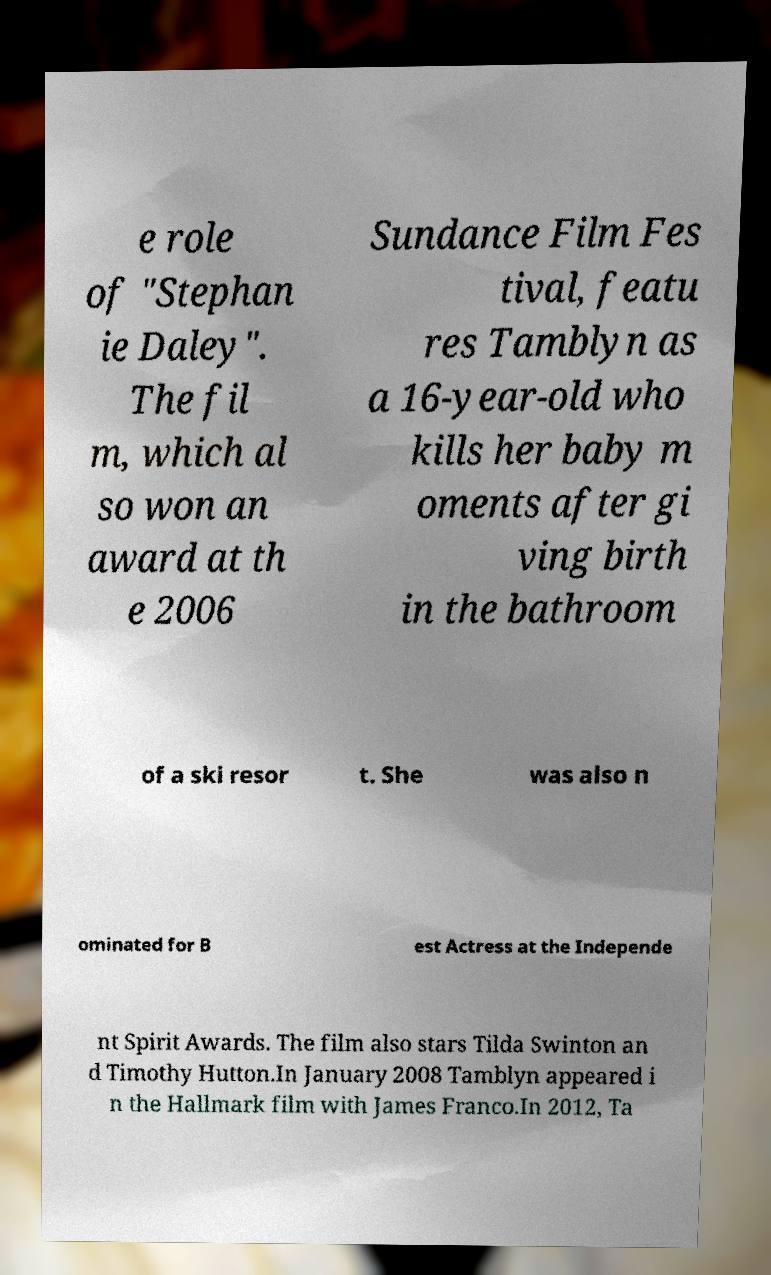Can you read and provide the text displayed in the image?This photo seems to have some interesting text. Can you extract and type it out for me? e role of "Stephan ie Daley". The fil m, which al so won an award at th e 2006 Sundance Film Fes tival, featu res Tamblyn as a 16-year-old who kills her baby m oments after gi ving birth in the bathroom of a ski resor t. She was also n ominated for B est Actress at the Independe nt Spirit Awards. The film also stars Tilda Swinton an d Timothy Hutton.In January 2008 Tamblyn appeared i n the Hallmark film with James Franco.In 2012, Ta 